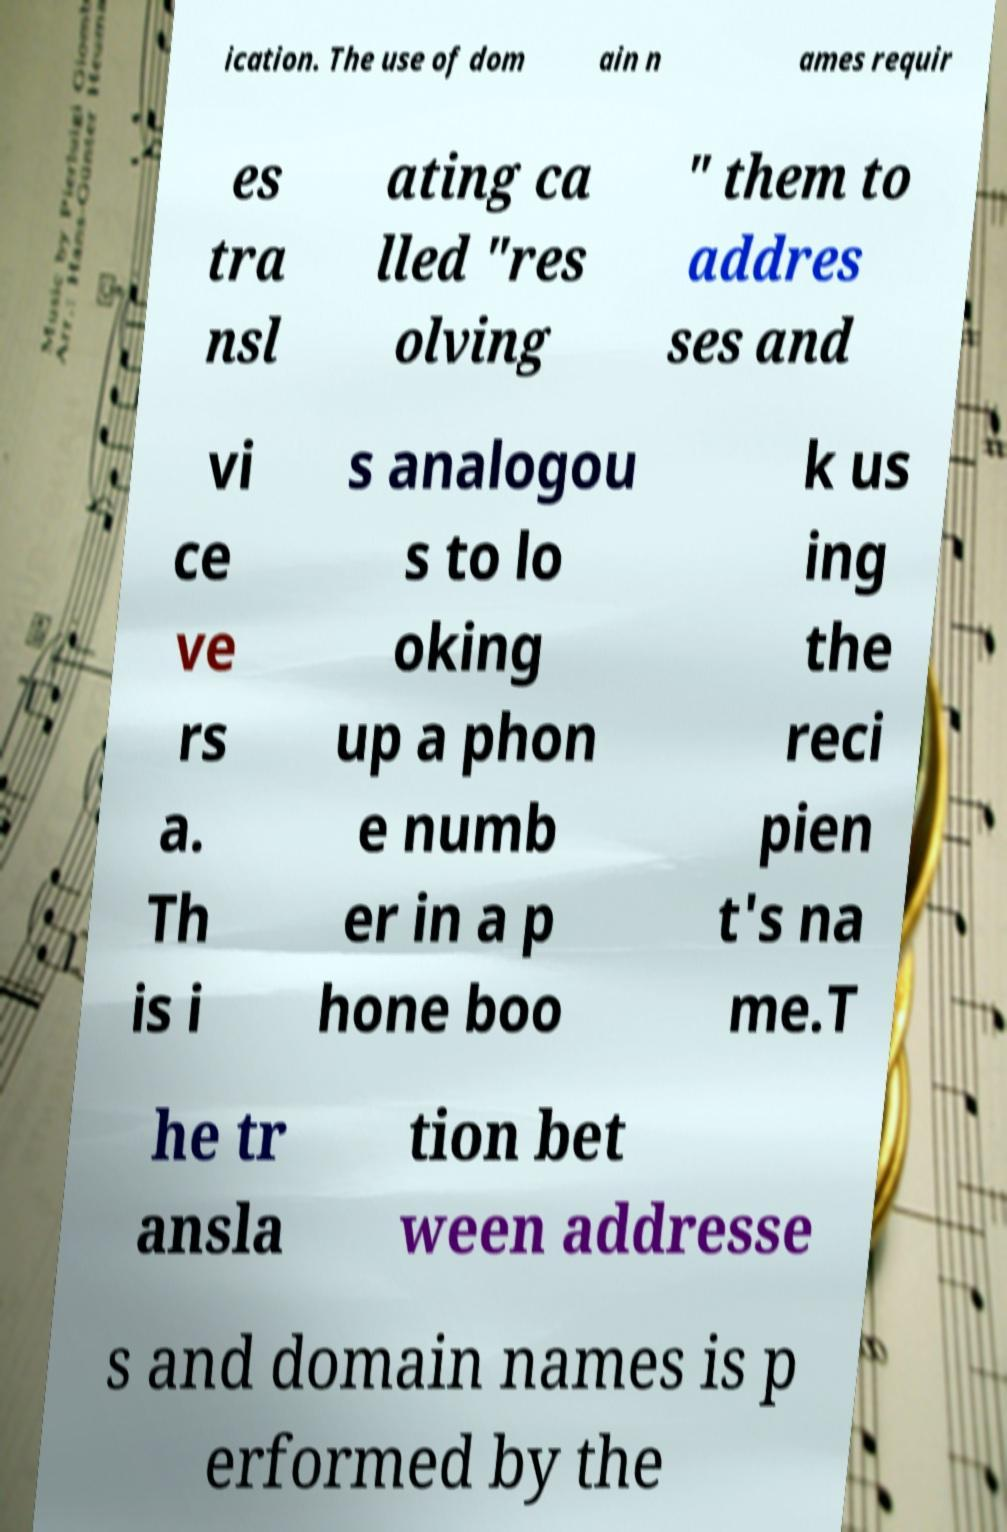Please read and relay the text visible in this image. What does it say? ication. The use of dom ain n ames requir es tra nsl ating ca lled "res olving " them to addres ses and vi ce ve rs a. Th is i s analogou s to lo oking up a phon e numb er in a p hone boo k us ing the reci pien t's na me.T he tr ansla tion bet ween addresse s and domain names is p erformed by the 